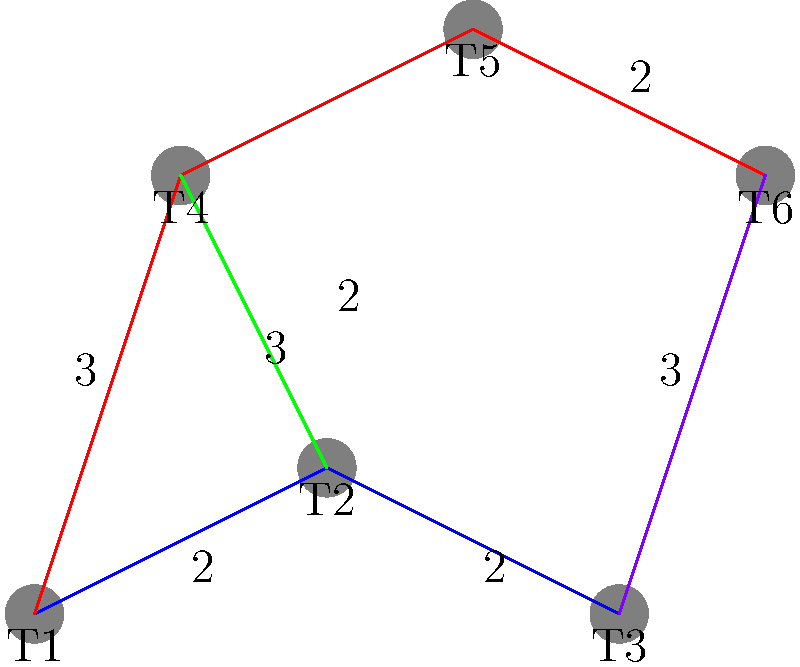In the restaurant floor plan shown above, tables are represented as circles labeled T1 through T6. The lines between tables represent paths, with their lengths indicated by numbers. As a busser, you need to find the shortest path from table T1 to table T6. What is the length of this shortest path? To find the shortest path from T1 to T6, we need to consider all possible routes and calculate their total lengths. Let's examine the options step by step:

1. Path 1 (blue + purple): T1 → T2 → T3 → T6
   Length = 2 + 2 + 3 = 7

2. Path 2 (red): T1 → T4 → T5 → T6
   Length = 3 + 2 + 2 = 7

3. Path 3 (green + red): T1 → T2 → T4 → T5 → T6
   Length = 2 + 3 + 2 + 2 = 9

4. Path 4 (blue + purple): T1 → T3 → T6
   Length = 4 + 3 = 7

After calculating all possible paths, we can see that there are three equally short paths with a length of 7:
- T1 → T2 → T3 → T6
- T1 → T4 → T5 → T6
- T1 → T3 → T6

Therefore, the length of the shortest path from T1 to T6 is 7.
Answer: 7 